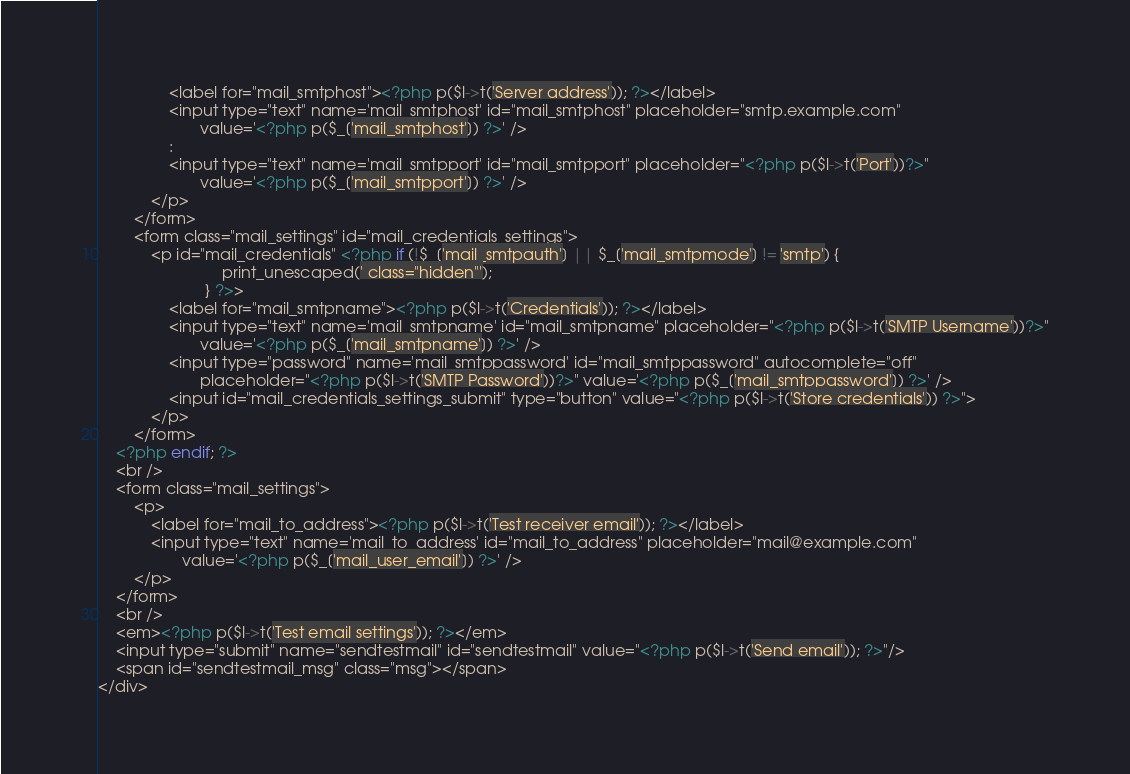Convert code to text. <code><loc_0><loc_0><loc_500><loc_500><_PHP_>				<label for="mail_smtphost"><?php p($l->t('Server address')); ?></label>
				<input type="text" name='mail_smtphost' id="mail_smtphost" placeholder="smtp.example.com"
					   value='<?php p($_['mail_smtphost']) ?>' />
				:
				<input type="text" name='mail_smtpport' id="mail_smtpport" placeholder="<?php p($l->t('Port'))?>"
					   value='<?php p($_['mail_smtpport']) ?>' />
			</p>
		</form>
		<form class="mail_settings" id="mail_credentials_settings">
			<p id="mail_credentials" <?php if (!$_['mail_smtpauth'] || $_['mail_smtpmode'] != 'smtp') {
							print_unescaped(' class="hidden"');
						} ?>>
				<label for="mail_smtpname"><?php p($l->t('Credentials')); ?></label>
				<input type="text" name='mail_smtpname' id="mail_smtpname" placeholder="<?php p($l->t('SMTP Username'))?>"
					   value='<?php p($_['mail_smtpname']) ?>' />
				<input type="password" name='mail_smtppassword' id="mail_smtppassword" autocomplete="off"
					   placeholder="<?php p($l->t('SMTP Password'))?>" value='<?php p($_['mail_smtppassword']) ?>' />
				<input id="mail_credentials_settings_submit" type="button" value="<?php p($l->t('Store credentials')) ?>">
			</p>
		</form>
	<?php endif; ?>
	<br />
	<form class="mail_settings">
		<p>
			<label for="mail_to_address"><?php p($l->t('Test receiver email')); ?></label>
			<input type="text" name='mail_to_address' id="mail_to_address" placeholder="mail@example.com"
				   value='<?php p($_['mail_user_email']) ?>' />
		</p>
	</form>
	<br />
	<em><?php p($l->t('Test email settings')); ?></em>
	<input type="submit" name="sendtestmail" id="sendtestmail" value="<?php p($l->t('Send email')); ?>"/>
	<span id="sendtestmail_msg" class="msg"></span>
</div>
</code> 